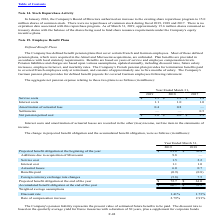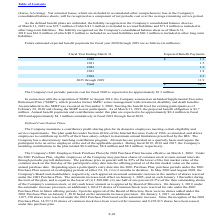From Microchip Technology's financial document, Which years does the table provide information for the change in projected benefit obligation and the accumulated benefit obligation? The document shows two values: 2019 and 2018. From the document: "2019 2018 2017 2019 2018 2017..." Also, What was the service cost in 2018? According to the financial document, 2.2 (in millions). The relevant text states: "Service cost 1.5 2.2..." Also, What was the interest cost in 2019? According to the financial document, 1.1 (in millions). The relevant text states: "Interest cost 1.1 1.0..." Also, can you calculate: What was the change in Service cost between 2018 and 2019? Based on the calculation: 1.5-2.2, the result is -0.7 (in millions). This is based on the information: "Service cost 1.5 2.2 Service cost 1.5 2.2..." The key data points involved are: 1.5, 2.2. Also, can you calculate: What was the change in the Discount rate between 2018 and 2019? Based on the calculation: 1.41-1.73, the result is -0.32 (percentage). This is based on the information: "Discount rate 1.41% 1.73% Discount rate 1.41% 1.73%..." The key data points involved are: 1.41, 1.73. Also, can you calculate: What was the percentage change in the Projected benefit obligation at the end of the year between 2018 and 2019? To answer this question, I need to perform calculations using the financial data. The calculation is: (72.7-61.0)/61.0, which equals 19.18 (percentage). This is based on the information: "benefit obligation at the beginning of the year $ 61.0 $ 50.4 ected benefit obligation at the end of the year $ 72.7 $ 61.0..." The key data points involved are: 61.0, 72.7. 